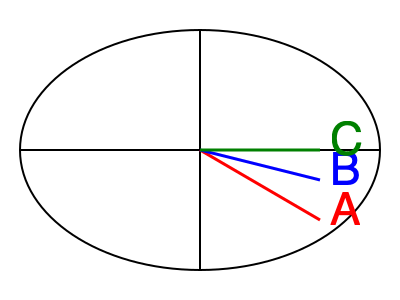In the anatomical illustration of the perineum above, which line represents a mediolateral episiotomy incision? To answer this question, let's review the types of episiotomy incisions represented in the diagram:

1. Line A (red): This line extends from the midline of the vaginal opening diagonally towards the ischial tuberosity. This angular incision is characteristic of a mediolateral episiotomy.

2. Line B (blue): This line is between the midline and the mediolateral position. It represents a modified mediolateral episiotomy.

3. Line C (green): This line extends straight out from the midline of the vaginal opening. It represents a midline (median) episiotomy.

The mediolateral episiotomy is defined as an incision that begins at the midline of the vaginal opening and extends at a 45-60 degree angle towards the ischial tuberosity. This type of incision reduces the risk of anal sphincter injury compared to a midline episiotomy.

In the diagram, the red line (A) clearly shows this angled trajectory, making it the correct representation of a mediolateral episiotomy incision.
Answer: A (red line) 